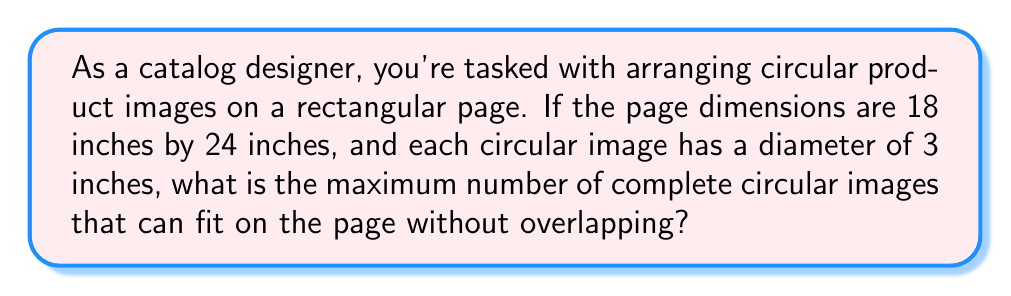What is the answer to this math problem? To solve this problem, we need to determine the most efficient packing of circles in a rectangle. The most efficient arrangement for circles is a hexagonal packing.

Step 1: Calculate the area of the page
$$A_{page} = 18 \text{ in} \times 24 \text{ in} = 432 \text{ sq in}$$

Step 2: Calculate the area of each circular image
$$A_{circle} = \pi r^2 = \pi (1.5 \text{ in})^2 \approx 7.0686 \text{ sq in}$$

Step 3: Determine the packing density of hexagonal arrangement
The packing density of circles in a hexagonal arrangement is approximately 0.9069.

Step 4: Calculate the theoretical maximum number of circles
$$N_{theoretical} = \frac{A_{page} \times 0.9069}{A_{circle}} \approx 55.23$$

Step 5: Round down to the nearest whole number
Since we can't have partial circles, we round down to 55.

Step 6: Verify the arrangement
[asy]
unitsize(0.15 inch);
for(int i = 0; i < 11; ++i)
  for(int j = 0; j < 5; ++j) {
    fill(circle((3*i, 2.6*j), 1.5), gray(0.8));
    fill(circle((3*i+1.5, 2.6*j+1.3), 1.5), gray(0.8));
  }
draw(box((0,0),(24,18)));
[/asy]

The diagram shows that 55 circles (5 rows of 11 circles) fit comfortably within the rectangle, confirming our calculation.
Answer: 55 circular images 